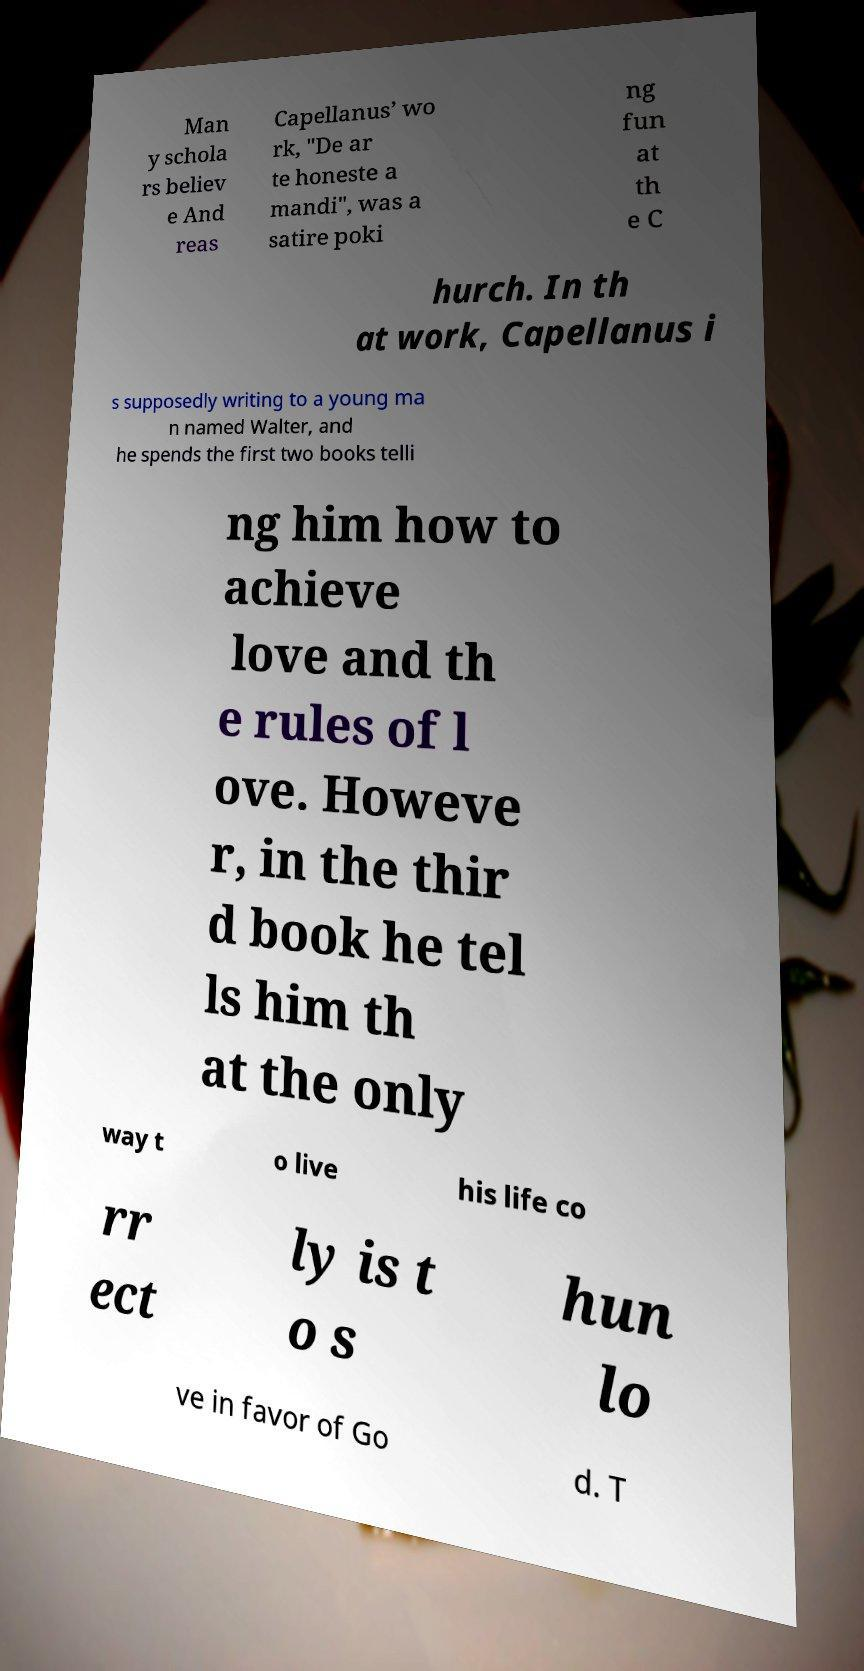Could you assist in decoding the text presented in this image and type it out clearly? Man y schola rs believ e And reas Capellanus’ wo rk, "De ar te honeste a mandi", was a satire poki ng fun at th e C hurch. In th at work, Capellanus i s supposedly writing to a young ma n named Walter, and he spends the first two books telli ng him how to achieve love and th e rules of l ove. Howeve r, in the thir d book he tel ls him th at the only way t o live his life co rr ect ly is t o s hun lo ve in favor of Go d. T 